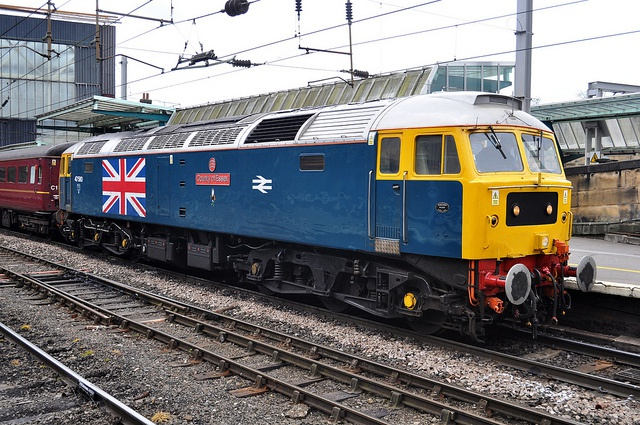Describe the objects in this image and their specific colors. I can see train in white, black, blue, and darkblue tones and people in white, darkgray, black, and tan tones in this image. 